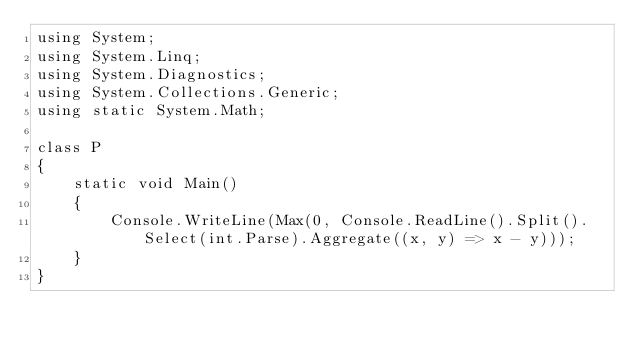Convert code to text. <code><loc_0><loc_0><loc_500><loc_500><_C#_>using System;
using System.Linq;
using System.Diagnostics;
using System.Collections.Generic;
using static System.Math;

class P
{
    static void Main()
    {
        Console.WriteLine(Max(0, Console.ReadLine().Split().Select(int.Parse).Aggregate((x, y) => x - y)));
    }
}</code> 